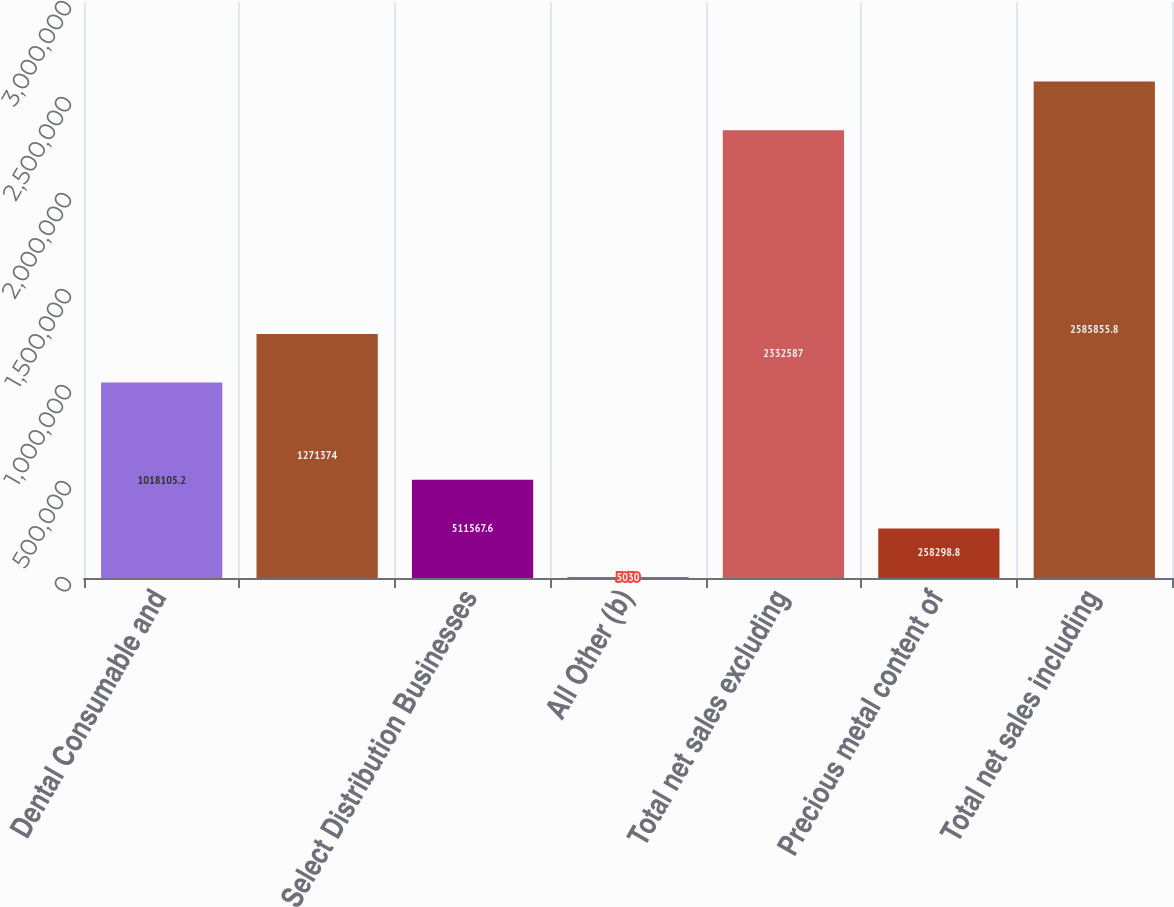Convert chart. <chart><loc_0><loc_0><loc_500><loc_500><bar_chart><fcel>Dental Consumable and<fcel>Unnamed: 1<fcel>Select Distribution Businesses<fcel>All Other (b)<fcel>Total net sales excluding<fcel>Precious metal content of<fcel>Total net sales including<nl><fcel>1.01811e+06<fcel>1.27137e+06<fcel>511568<fcel>5030<fcel>2.33259e+06<fcel>258299<fcel>2.58586e+06<nl></chart> 